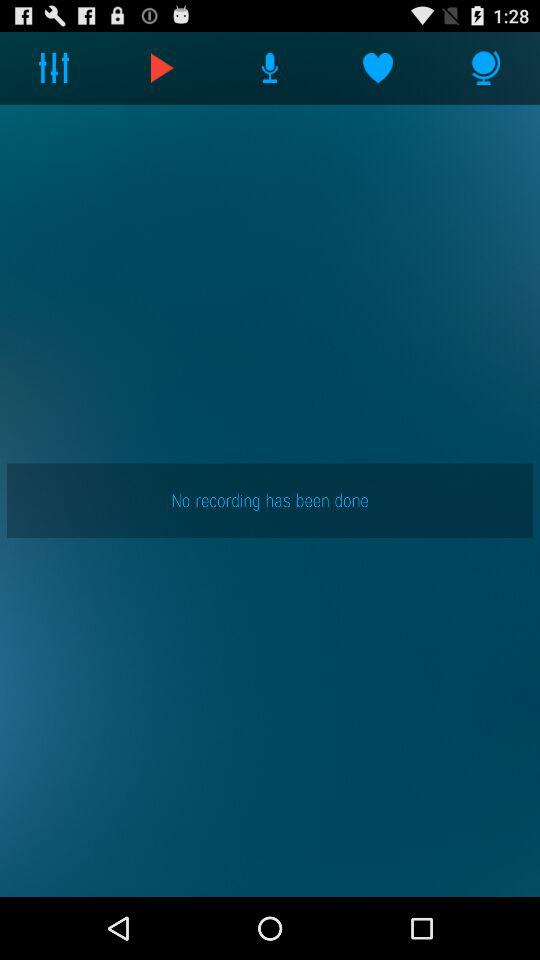How many recordings are done? There have been no recordings done. 